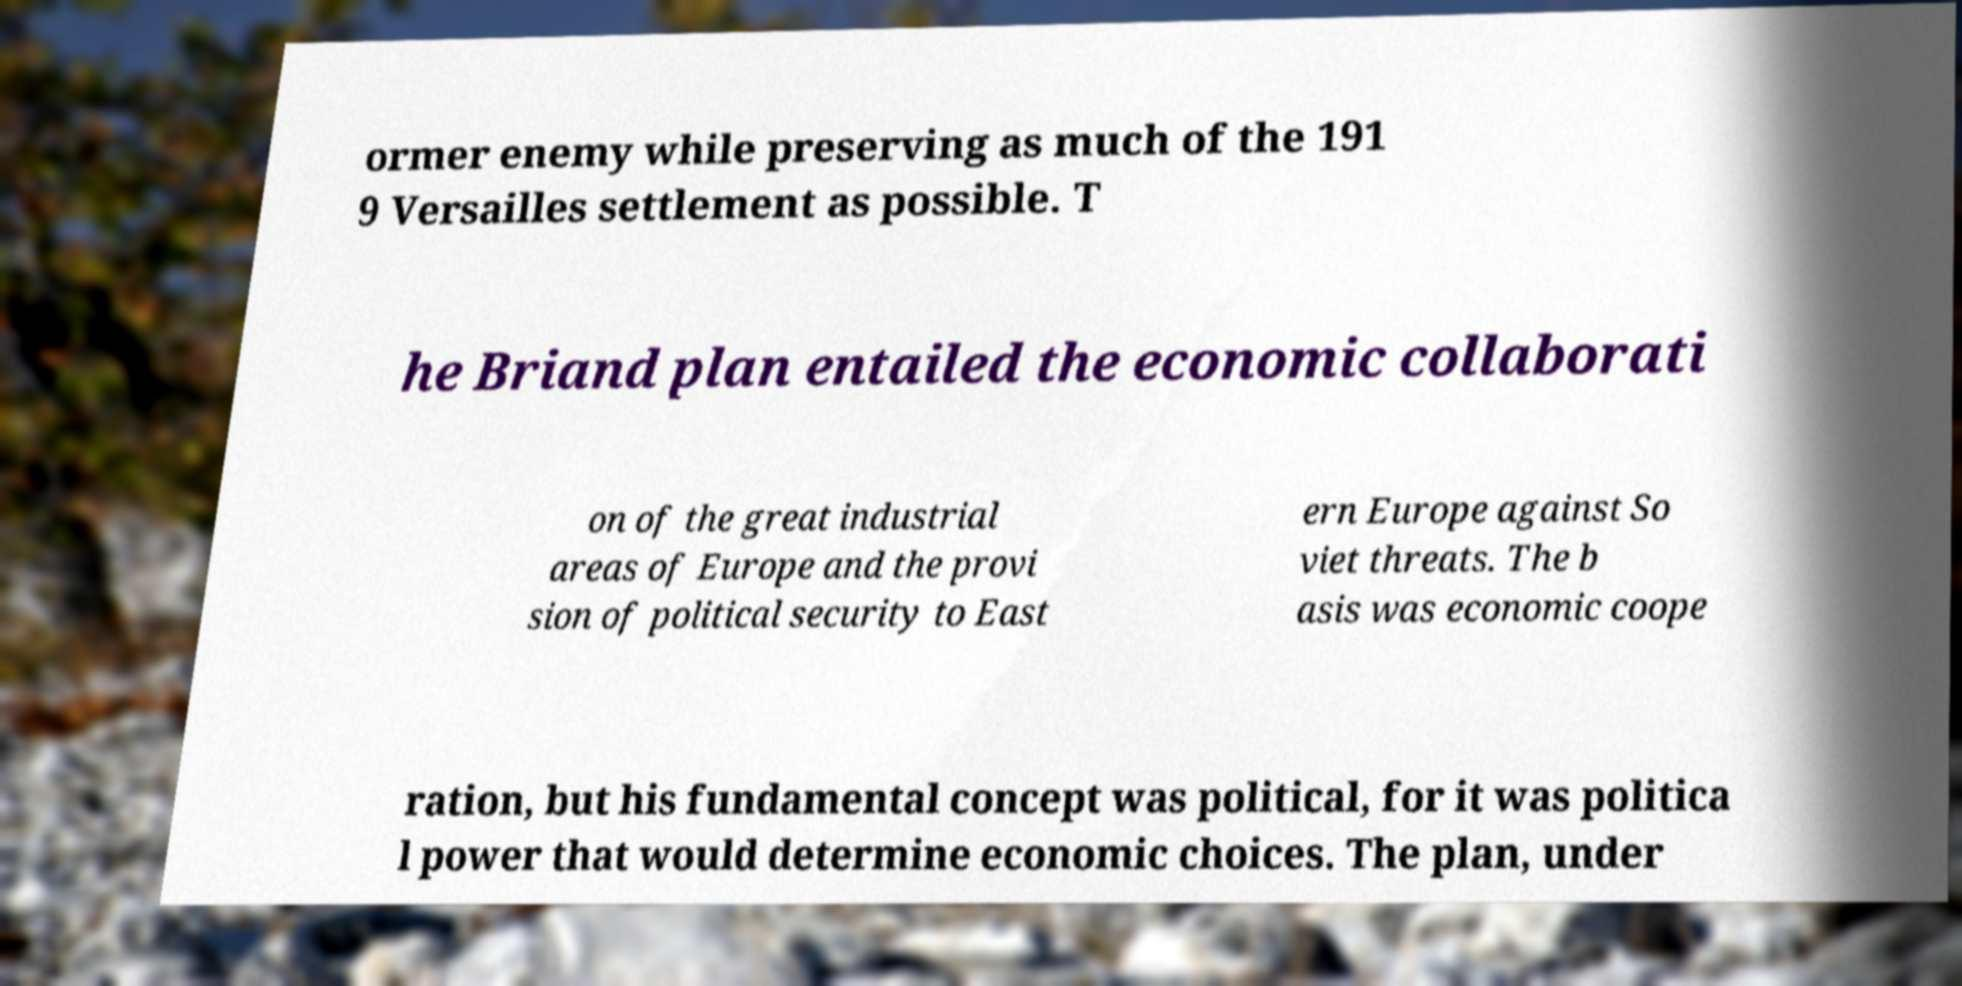For documentation purposes, I need the text within this image transcribed. Could you provide that? ormer enemy while preserving as much of the 191 9 Versailles settlement as possible. T he Briand plan entailed the economic collaborati on of the great industrial areas of Europe and the provi sion of political security to East ern Europe against So viet threats. The b asis was economic coope ration, but his fundamental concept was political, for it was politica l power that would determine economic choices. The plan, under 